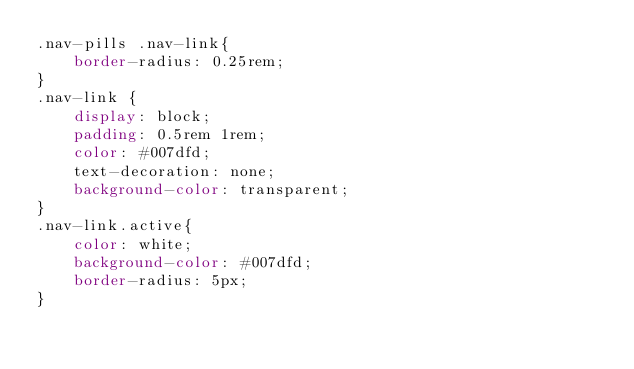<code> <loc_0><loc_0><loc_500><loc_500><_CSS_>.nav-pills .nav-link{
    border-radius: 0.25rem;
}
.nav-link {
    display: block;
    padding: 0.5rem 1rem;
    color: #007dfd;
    text-decoration: none;
    background-color: transparent;
}
.nav-link.active{
    color: white;
    background-color: #007dfd;
    border-radius: 5px;
}
</code> 